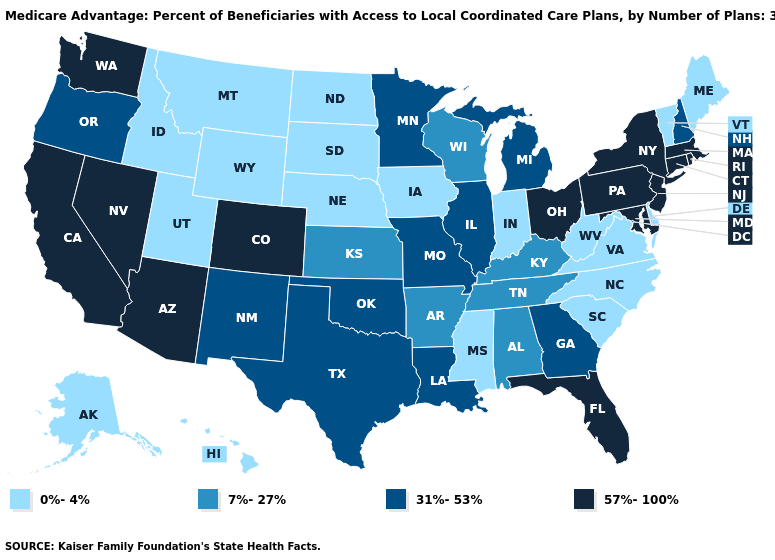What is the highest value in states that border Arizona?
Quick response, please. 57%-100%. Name the states that have a value in the range 31%-53%?
Concise answer only. Georgia, Illinois, Louisiana, Michigan, Minnesota, Missouri, New Hampshire, New Mexico, Oklahoma, Oregon, Texas. Which states have the lowest value in the USA?
Be succinct. Alaska, Delaware, Hawaii, Iowa, Idaho, Indiana, Maine, Mississippi, Montana, North Carolina, North Dakota, Nebraska, South Carolina, South Dakota, Utah, Virginia, Vermont, West Virginia, Wyoming. Name the states that have a value in the range 7%-27%?
Quick response, please. Alabama, Arkansas, Kansas, Kentucky, Tennessee, Wisconsin. Which states have the lowest value in the South?
Quick response, please. Delaware, Mississippi, North Carolina, South Carolina, Virginia, West Virginia. Does the map have missing data?
Answer briefly. No. Does the first symbol in the legend represent the smallest category?
Write a very short answer. Yes. What is the value of California?
Give a very brief answer. 57%-100%. What is the highest value in states that border Idaho?
Quick response, please. 57%-100%. Name the states that have a value in the range 7%-27%?
Write a very short answer. Alabama, Arkansas, Kansas, Kentucky, Tennessee, Wisconsin. What is the value of Wisconsin?
Answer briefly. 7%-27%. What is the value of Washington?
Quick response, please. 57%-100%. What is the value of Minnesota?
Write a very short answer. 31%-53%. What is the value of Washington?
Answer briefly. 57%-100%. Among the states that border Wisconsin , does Iowa have the highest value?
Concise answer only. No. 